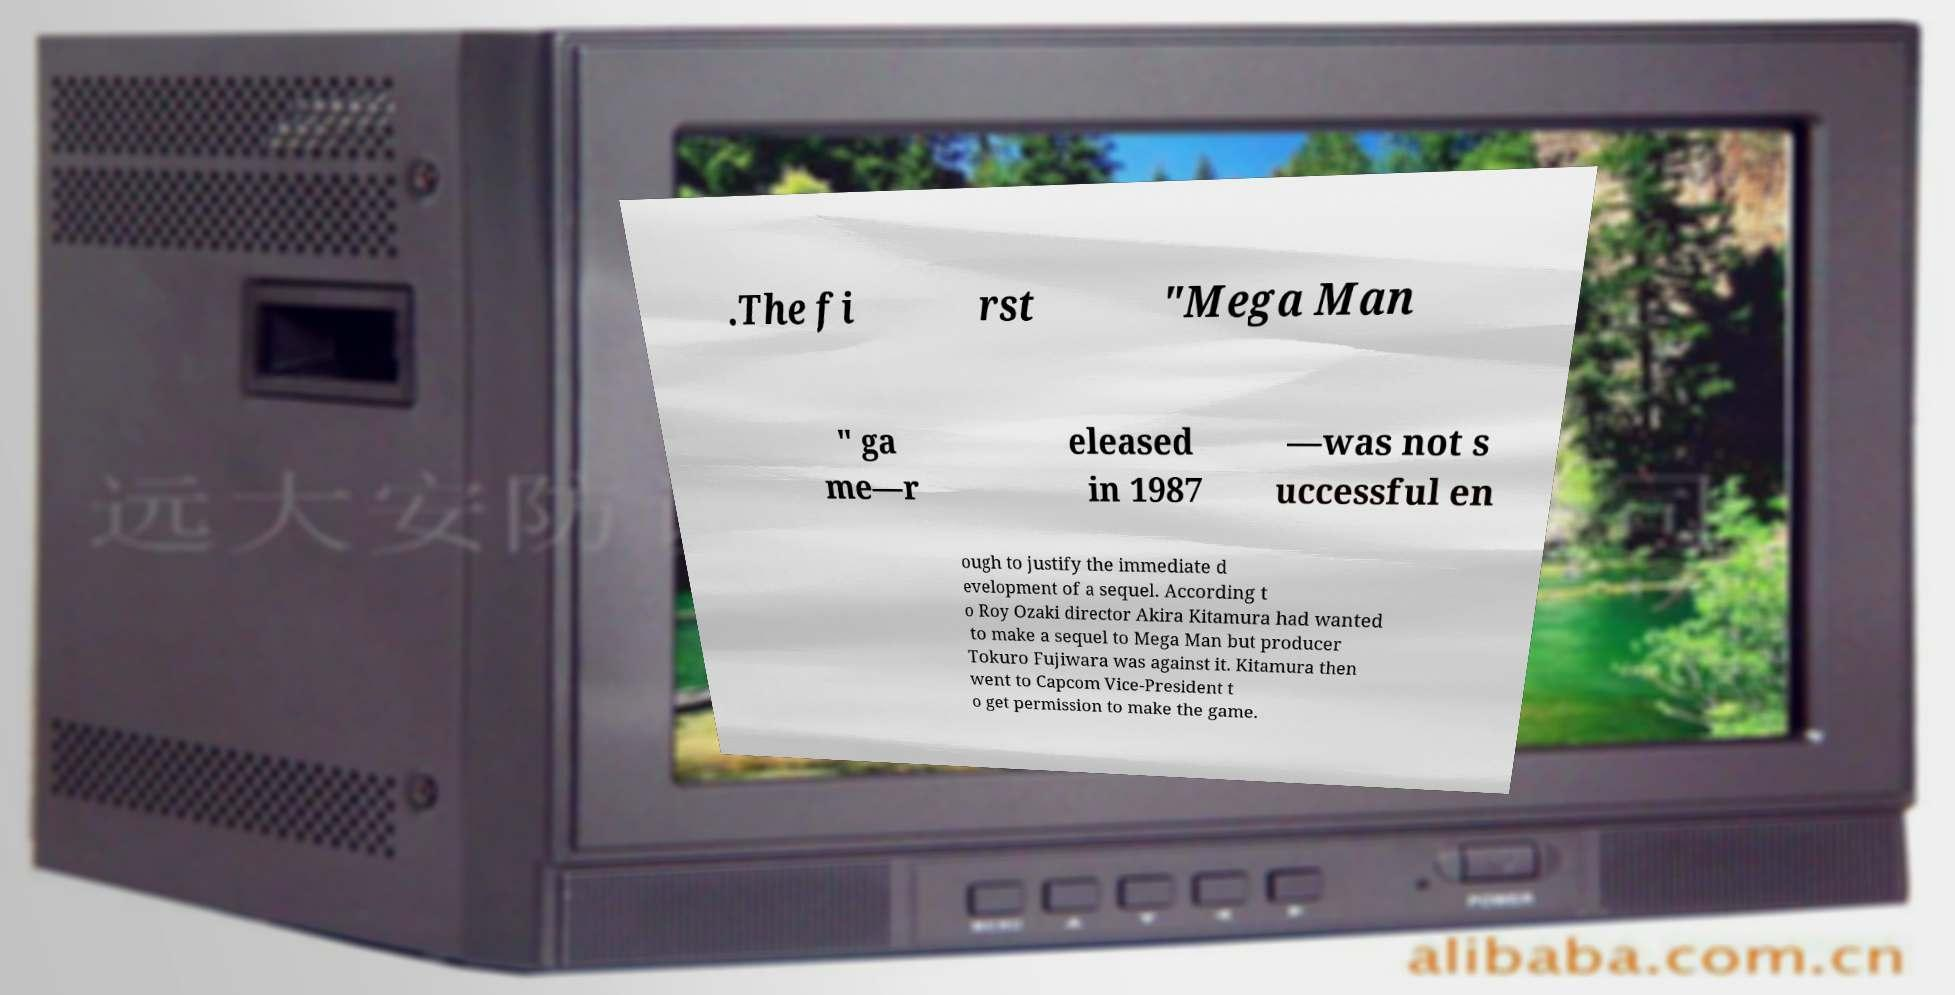What messages or text are displayed in this image? I need them in a readable, typed format. .The fi rst "Mega Man " ga me—r eleased in 1987 —was not s uccessful en ough to justify the immediate d evelopment of a sequel. According t o Roy Ozaki director Akira Kitamura had wanted to make a sequel to Mega Man but producer Tokuro Fujiwara was against it. Kitamura then went to Capcom Vice-President t o get permission to make the game. 